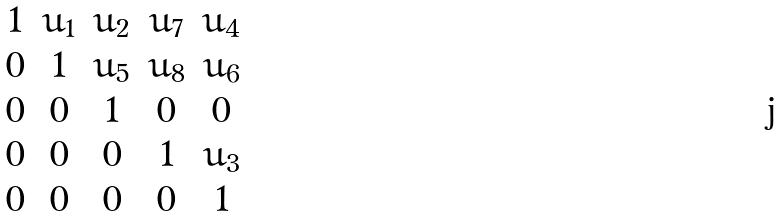Convert formula to latex. <formula><loc_0><loc_0><loc_500><loc_500>\begin{matrix} 1 & u _ { 1 } & u _ { 2 } & u _ { 7 } & u _ { 4 } \\ 0 & 1 & u _ { 5 } & u _ { 8 } & u _ { 6 } \\ 0 & 0 & 1 & 0 & 0 \\ 0 & 0 & 0 & 1 & u _ { 3 } \\ 0 & 0 & 0 & 0 & 1 \end{matrix}</formula> 